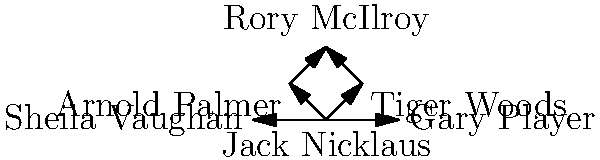In this network diagram of famous golfers and their influences, which golfer has directly influenced the most other golfers according to the graph? To answer this question, we need to analyze the network diagram and count the number of outgoing arrows (influences) for each golfer:

1. Jack Nicklaus: 4 outgoing arrows (to Tiger Woods, Arnold Palmer, Sheila Vaughan, and Gary Player)
2. Tiger Woods: 1 outgoing arrow (to Rory McIlroy)
3. Arnold Palmer: 1 outgoing arrow (to Rory McIlroy)
4. Rory McIlroy: 0 outgoing arrows
5. Sheila Vaughan: 0 outgoing arrows
6. Gary Player: 0 outgoing arrows

By counting the outgoing arrows, we can see that Jack Nicklaus has directly influenced the most other golfers with 4 connections.
Answer: Jack Nicklaus 